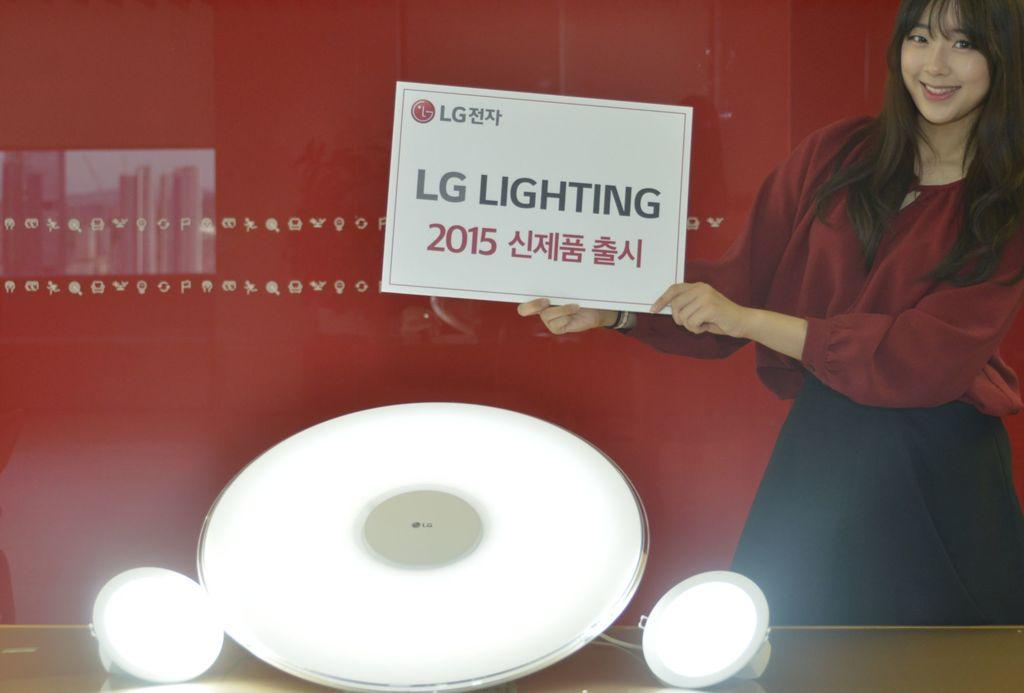Who is the main subject in the image? There is a girl in the image. What is the girl holding in her hand? The girl is holding a board in her hand. What can be seen in front of the girl? There are white objects in front of the girl. What color is the wall in the background of the image? There is a red wall in the background of the image. What type of mine is visible in the image? There is no mine present in the image. How many buns are on the girl's head in the image? There are no buns visible on the girl's head in the image. 